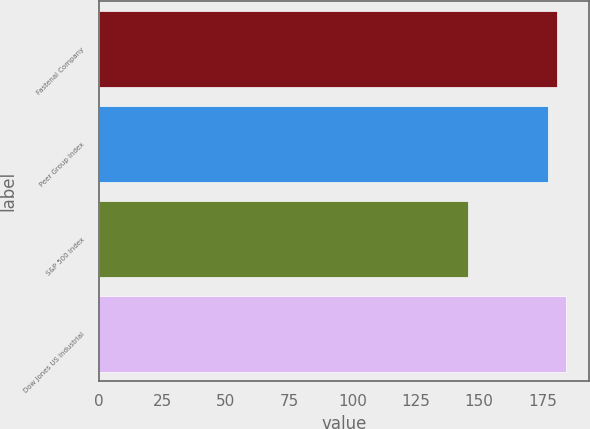Convert chart. <chart><loc_0><loc_0><loc_500><loc_500><bar_chart><fcel>Fastenal Company<fcel>Peer Group Index<fcel>S&P 500 Index<fcel>Dow Jones US Industrial<nl><fcel>180.69<fcel>177.17<fcel>145.51<fcel>184.21<nl></chart> 